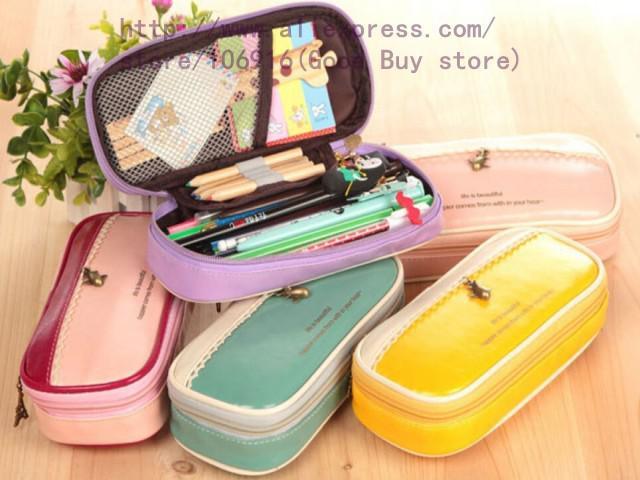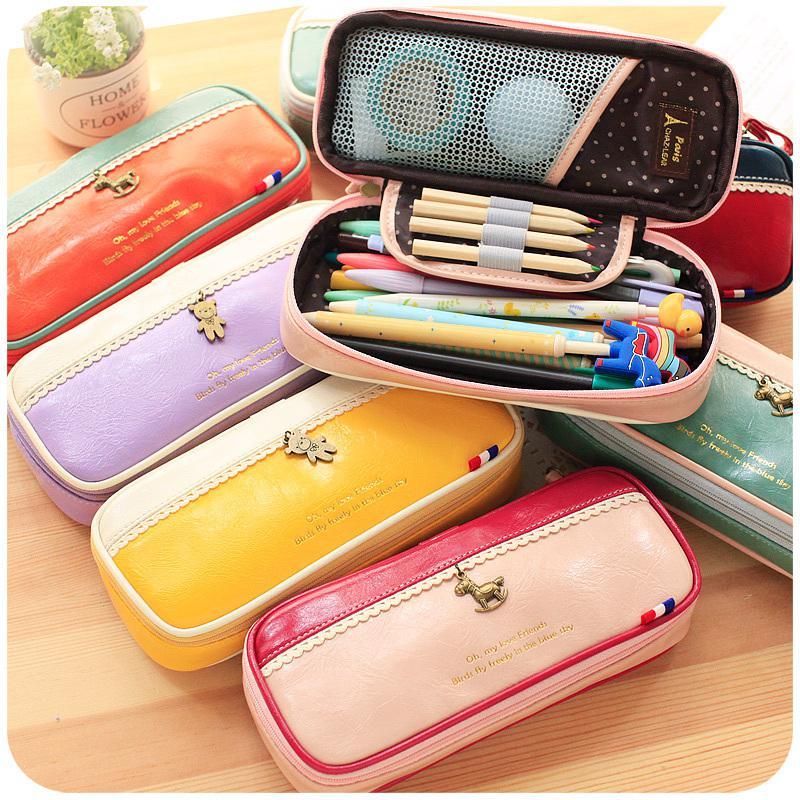The first image is the image on the left, the second image is the image on the right. For the images displayed, is the sentence "The open pouch in one of the images contains an electronic device." factually correct? Answer yes or no. No. 